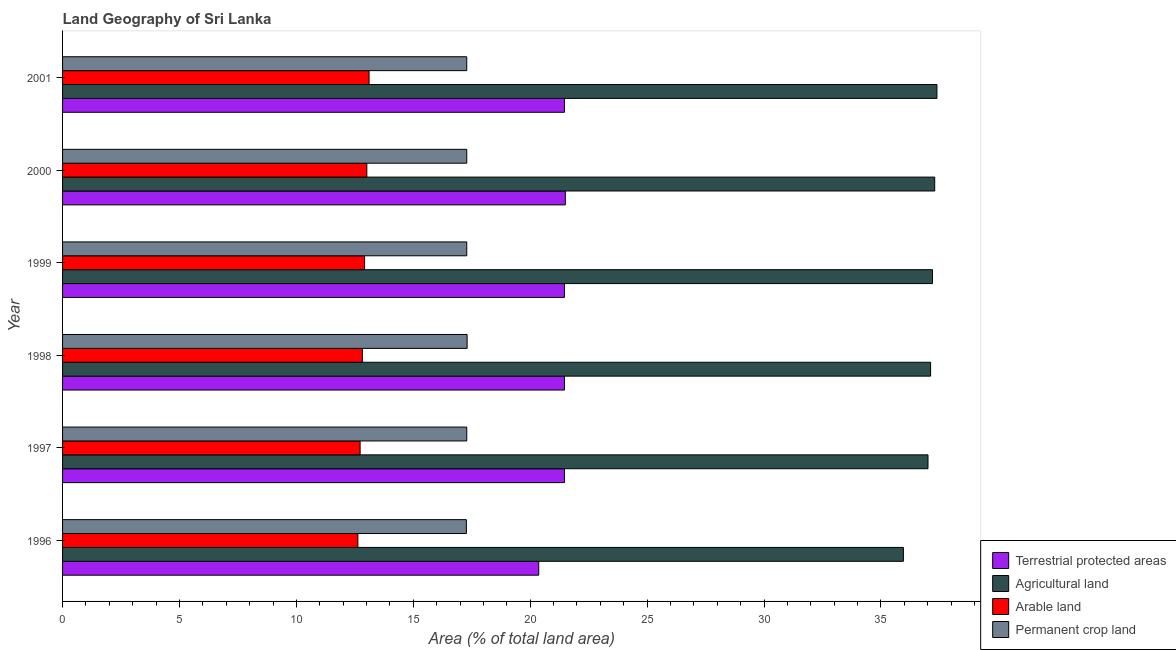How many different coloured bars are there?
Offer a terse response. 4. What is the percentage of area under agricultural land in 1997?
Ensure brevity in your answer.  37.01. Across all years, what is the maximum percentage of area under permanent crop land?
Your answer should be compact. 17.3. Across all years, what is the minimum percentage of area under arable land?
Your response must be concise. 12.63. What is the total percentage of area under arable land in the graph?
Your answer should be very brief. 77.21. What is the difference between the percentage of area under agricultural land in 1996 and that in 1997?
Your answer should be very brief. -1.05. What is the difference between the percentage of area under agricultural land in 1997 and the percentage of land under terrestrial protection in 1996?
Provide a short and direct response. 16.65. What is the average percentage of area under agricultural land per year?
Give a very brief answer. 37. In the year 1997, what is the difference between the percentage of land under terrestrial protection and percentage of area under agricultural land?
Give a very brief answer. -15.55. Is the percentage of area under arable land in 1997 less than that in 2000?
Make the answer very short. Yes. What is the difference between the highest and the second highest percentage of area under agricultural land?
Give a very brief answer. 0.1. What is the difference between the highest and the lowest percentage of area under agricultural land?
Your answer should be compact. 1.44. Is the sum of the percentage of land under terrestrial protection in 1998 and 1999 greater than the maximum percentage of area under arable land across all years?
Provide a short and direct response. Yes. What does the 3rd bar from the top in 1996 represents?
Ensure brevity in your answer.  Agricultural land. What does the 2nd bar from the bottom in 1996 represents?
Provide a short and direct response. Agricultural land. Are all the bars in the graph horizontal?
Your answer should be very brief. Yes. How many years are there in the graph?
Give a very brief answer. 6. Does the graph contain any zero values?
Keep it short and to the point. No. How many legend labels are there?
Your answer should be compact. 4. What is the title of the graph?
Give a very brief answer. Land Geography of Sri Lanka. Does "Arable land" appear as one of the legend labels in the graph?
Your answer should be very brief. Yes. What is the label or title of the X-axis?
Ensure brevity in your answer.  Area (% of total land area). What is the label or title of the Y-axis?
Your answer should be compact. Year. What is the Area (% of total land area) of Terrestrial protected areas in 1996?
Your response must be concise. 20.36. What is the Area (% of total land area) of Agricultural land in 1996?
Provide a short and direct response. 35.96. What is the Area (% of total land area) in Arable land in 1996?
Provide a succinct answer. 12.63. What is the Area (% of total land area) of Permanent crop land in 1996?
Ensure brevity in your answer.  17.27. What is the Area (% of total land area) in Terrestrial protected areas in 1997?
Provide a short and direct response. 21.46. What is the Area (% of total land area) in Agricultural land in 1997?
Your answer should be very brief. 37.01. What is the Area (% of total land area) of Arable land in 1997?
Your answer should be compact. 12.73. What is the Area (% of total land area) of Permanent crop land in 1997?
Provide a succinct answer. 17.29. What is the Area (% of total land area) of Terrestrial protected areas in 1998?
Keep it short and to the point. 21.46. What is the Area (% of total land area) of Agricultural land in 1998?
Your answer should be compact. 37.12. What is the Area (% of total land area) of Arable land in 1998?
Make the answer very short. 12.82. What is the Area (% of total land area) in Permanent crop land in 1998?
Offer a very short reply. 17.3. What is the Area (% of total land area) of Terrestrial protected areas in 1999?
Provide a short and direct response. 21.46. What is the Area (% of total land area) of Agricultural land in 1999?
Your response must be concise. 37.2. What is the Area (% of total land area) of Arable land in 1999?
Offer a very short reply. 12.92. What is the Area (% of total land area) of Permanent crop land in 1999?
Provide a succinct answer. 17.29. What is the Area (% of total land area) in Terrestrial protected areas in 2000?
Provide a succinct answer. 21.5. What is the Area (% of total land area) in Agricultural land in 2000?
Your response must be concise. 37.3. What is the Area (% of total land area) in Arable land in 2000?
Your answer should be compact. 13.01. What is the Area (% of total land area) in Permanent crop land in 2000?
Your answer should be compact. 17.29. What is the Area (% of total land area) of Terrestrial protected areas in 2001?
Ensure brevity in your answer.  21.46. What is the Area (% of total land area) in Agricultural land in 2001?
Your response must be concise. 37.39. What is the Area (% of total land area) in Arable land in 2001?
Your answer should be compact. 13.11. What is the Area (% of total land area) in Permanent crop land in 2001?
Offer a terse response. 17.29. Across all years, what is the maximum Area (% of total land area) of Terrestrial protected areas?
Give a very brief answer. 21.5. Across all years, what is the maximum Area (% of total land area) in Agricultural land?
Your answer should be compact. 37.39. Across all years, what is the maximum Area (% of total land area) in Arable land?
Provide a succinct answer. 13.11. Across all years, what is the maximum Area (% of total land area) in Permanent crop land?
Your answer should be compact. 17.3. Across all years, what is the minimum Area (% of total land area) of Terrestrial protected areas?
Provide a short and direct response. 20.36. Across all years, what is the minimum Area (% of total land area) of Agricultural land?
Provide a short and direct response. 35.96. Across all years, what is the minimum Area (% of total land area) of Arable land?
Offer a terse response. 12.63. Across all years, what is the minimum Area (% of total land area) in Permanent crop land?
Offer a terse response. 17.27. What is the total Area (% of total land area) in Terrestrial protected areas in the graph?
Give a very brief answer. 127.72. What is the total Area (% of total land area) in Agricultural land in the graph?
Offer a terse response. 221.99. What is the total Area (% of total land area) of Arable land in the graph?
Your response must be concise. 77.21. What is the total Area (% of total land area) of Permanent crop land in the graph?
Give a very brief answer. 103.72. What is the difference between the Area (% of total land area) in Terrestrial protected areas in 1996 and that in 1997?
Your answer should be very brief. -1.1. What is the difference between the Area (% of total land area) of Agricultural land in 1996 and that in 1997?
Ensure brevity in your answer.  -1.05. What is the difference between the Area (% of total land area) in Arable land in 1996 and that in 1997?
Your answer should be very brief. -0.1. What is the difference between the Area (% of total land area) in Permanent crop land in 1996 and that in 1997?
Offer a very short reply. -0.02. What is the difference between the Area (% of total land area) in Terrestrial protected areas in 1996 and that in 1998?
Offer a terse response. -1.1. What is the difference between the Area (% of total land area) in Agricultural land in 1996 and that in 1998?
Your response must be concise. -1.16. What is the difference between the Area (% of total land area) in Arable land in 1996 and that in 1998?
Give a very brief answer. -0.19. What is the difference between the Area (% of total land area) in Permanent crop land in 1996 and that in 1998?
Provide a succinct answer. -0.03. What is the difference between the Area (% of total land area) of Terrestrial protected areas in 1996 and that in 1999?
Your answer should be very brief. -1.1. What is the difference between the Area (% of total land area) of Agricultural land in 1996 and that in 1999?
Your answer should be very brief. -1.24. What is the difference between the Area (% of total land area) of Arable land in 1996 and that in 1999?
Offer a terse response. -0.29. What is the difference between the Area (% of total land area) of Permanent crop land in 1996 and that in 1999?
Make the answer very short. -0.02. What is the difference between the Area (% of total land area) in Terrestrial protected areas in 1996 and that in 2000?
Make the answer very short. -1.14. What is the difference between the Area (% of total land area) of Agricultural land in 1996 and that in 2000?
Keep it short and to the point. -1.34. What is the difference between the Area (% of total land area) in Arable land in 1996 and that in 2000?
Give a very brief answer. -0.38. What is the difference between the Area (% of total land area) of Permanent crop land in 1996 and that in 2000?
Offer a terse response. -0.02. What is the difference between the Area (% of total land area) of Terrestrial protected areas in 1996 and that in 2001?
Make the answer very short. -1.1. What is the difference between the Area (% of total land area) in Agricultural land in 1996 and that in 2001?
Your response must be concise. -1.44. What is the difference between the Area (% of total land area) of Arable land in 1996 and that in 2001?
Keep it short and to the point. -0.48. What is the difference between the Area (% of total land area) in Permanent crop land in 1996 and that in 2001?
Offer a terse response. -0.02. What is the difference between the Area (% of total land area) of Agricultural land in 1997 and that in 1998?
Offer a very short reply. -0.11. What is the difference between the Area (% of total land area) of Arable land in 1997 and that in 1998?
Make the answer very short. -0.1. What is the difference between the Area (% of total land area) in Permanent crop land in 1997 and that in 1998?
Ensure brevity in your answer.  -0.02. What is the difference between the Area (% of total land area) in Agricultural land in 1997 and that in 1999?
Your answer should be very brief. -0.19. What is the difference between the Area (% of total land area) of Arable land in 1997 and that in 1999?
Make the answer very short. -0.19. What is the difference between the Area (% of total land area) in Permanent crop land in 1997 and that in 1999?
Your answer should be very brief. 0. What is the difference between the Area (% of total land area) in Terrestrial protected areas in 1997 and that in 2000?
Your response must be concise. -0.04. What is the difference between the Area (% of total land area) in Agricultural land in 1997 and that in 2000?
Offer a terse response. -0.29. What is the difference between the Area (% of total land area) of Arable land in 1997 and that in 2000?
Your response must be concise. -0.29. What is the difference between the Area (% of total land area) in Agricultural land in 1997 and that in 2001?
Offer a very short reply. -0.38. What is the difference between the Area (% of total land area) in Arable land in 1997 and that in 2001?
Your answer should be very brief. -0.38. What is the difference between the Area (% of total land area) in Terrestrial protected areas in 1998 and that in 1999?
Ensure brevity in your answer.  0. What is the difference between the Area (% of total land area) in Agricultural land in 1998 and that in 1999?
Your answer should be compact. -0.08. What is the difference between the Area (% of total land area) of Arable land in 1998 and that in 1999?
Offer a very short reply. -0.1. What is the difference between the Area (% of total land area) of Permanent crop land in 1998 and that in 1999?
Give a very brief answer. 0.02. What is the difference between the Area (% of total land area) in Terrestrial protected areas in 1998 and that in 2000?
Your answer should be very brief. -0.04. What is the difference between the Area (% of total land area) of Agricultural land in 1998 and that in 2000?
Offer a terse response. -0.18. What is the difference between the Area (% of total land area) in Arable land in 1998 and that in 2000?
Provide a short and direct response. -0.19. What is the difference between the Area (% of total land area) in Permanent crop land in 1998 and that in 2000?
Keep it short and to the point. 0.02. What is the difference between the Area (% of total land area) of Terrestrial protected areas in 1998 and that in 2001?
Provide a succinct answer. 0. What is the difference between the Area (% of total land area) of Agricultural land in 1998 and that in 2001?
Offer a terse response. -0.27. What is the difference between the Area (% of total land area) of Arable land in 1998 and that in 2001?
Your answer should be compact. -0.29. What is the difference between the Area (% of total land area) of Permanent crop land in 1998 and that in 2001?
Offer a very short reply. 0.02. What is the difference between the Area (% of total land area) in Terrestrial protected areas in 1999 and that in 2000?
Make the answer very short. -0.04. What is the difference between the Area (% of total land area) in Agricultural land in 1999 and that in 2000?
Provide a succinct answer. -0.1. What is the difference between the Area (% of total land area) of Arable land in 1999 and that in 2000?
Ensure brevity in your answer.  -0.1. What is the difference between the Area (% of total land area) of Permanent crop land in 1999 and that in 2000?
Offer a very short reply. 0. What is the difference between the Area (% of total land area) in Terrestrial protected areas in 1999 and that in 2001?
Provide a succinct answer. 0. What is the difference between the Area (% of total land area) in Agricultural land in 1999 and that in 2001?
Keep it short and to the point. -0.19. What is the difference between the Area (% of total land area) of Arable land in 1999 and that in 2001?
Your response must be concise. -0.19. What is the difference between the Area (% of total land area) of Permanent crop land in 1999 and that in 2001?
Keep it short and to the point. 0. What is the difference between the Area (% of total land area) in Terrestrial protected areas in 2000 and that in 2001?
Keep it short and to the point. 0.04. What is the difference between the Area (% of total land area) in Agricultural land in 2000 and that in 2001?
Provide a succinct answer. -0.1. What is the difference between the Area (% of total land area) in Arable land in 2000 and that in 2001?
Keep it short and to the point. -0.1. What is the difference between the Area (% of total land area) in Terrestrial protected areas in 1996 and the Area (% of total land area) in Agricultural land in 1997?
Offer a terse response. -16.65. What is the difference between the Area (% of total land area) in Terrestrial protected areas in 1996 and the Area (% of total land area) in Arable land in 1997?
Provide a short and direct response. 7.64. What is the difference between the Area (% of total land area) of Terrestrial protected areas in 1996 and the Area (% of total land area) of Permanent crop land in 1997?
Offer a very short reply. 3.08. What is the difference between the Area (% of total land area) in Agricultural land in 1996 and the Area (% of total land area) in Arable land in 1997?
Provide a short and direct response. 23.23. What is the difference between the Area (% of total land area) in Agricultural land in 1996 and the Area (% of total land area) in Permanent crop land in 1997?
Your answer should be very brief. 18.67. What is the difference between the Area (% of total land area) in Arable land in 1996 and the Area (% of total land area) in Permanent crop land in 1997?
Make the answer very short. -4.66. What is the difference between the Area (% of total land area) of Terrestrial protected areas in 1996 and the Area (% of total land area) of Agricultural land in 1998?
Offer a very short reply. -16.76. What is the difference between the Area (% of total land area) in Terrestrial protected areas in 1996 and the Area (% of total land area) in Arable land in 1998?
Ensure brevity in your answer.  7.54. What is the difference between the Area (% of total land area) in Terrestrial protected areas in 1996 and the Area (% of total land area) in Permanent crop land in 1998?
Your answer should be compact. 3.06. What is the difference between the Area (% of total land area) of Agricultural land in 1996 and the Area (% of total land area) of Arable land in 1998?
Your answer should be very brief. 23.14. What is the difference between the Area (% of total land area) of Agricultural land in 1996 and the Area (% of total land area) of Permanent crop land in 1998?
Offer a very short reply. 18.66. What is the difference between the Area (% of total land area) of Arable land in 1996 and the Area (% of total land area) of Permanent crop land in 1998?
Your answer should be compact. -4.67. What is the difference between the Area (% of total land area) in Terrestrial protected areas in 1996 and the Area (% of total land area) in Agricultural land in 1999?
Offer a terse response. -16.84. What is the difference between the Area (% of total land area) of Terrestrial protected areas in 1996 and the Area (% of total land area) of Arable land in 1999?
Provide a short and direct response. 7.45. What is the difference between the Area (% of total land area) of Terrestrial protected areas in 1996 and the Area (% of total land area) of Permanent crop land in 1999?
Make the answer very short. 3.08. What is the difference between the Area (% of total land area) in Agricultural land in 1996 and the Area (% of total land area) in Arable land in 1999?
Ensure brevity in your answer.  23.04. What is the difference between the Area (% of total land area) of Agricultural land in 1996 and the Area (% of total land area) of Permanent crop land in 1999?
Make the answer very short. 18.67. What is the difference between the Area (% of total land area) of Arable land in 1996 and the Area (% of total land area) of Permanent crop land in 1999?
Offer a terse response. -4.66. What is the difference between the Area (% of total land area) in Terrestrial protected areas in 1996 and the Area (% of total land area) in Agricultural land in 2000?
Keep it short and to the point. -16.93. What is the difference between the Area (% of total land area) in Terrestrial protected areas in 1996 and the Area (% of total land area) in Arable land in 2000?
Ensure brevity in your answer.  7.35. What is the difference between the Area (% of total land area) of Terrestrial protected areas in 1996 and the Area (% of total land area) of Permanent crop land in 2000?
Your answer should be very brief. 3.08. What is the difference between the Area (% of total land area) of Agricultural land in 1996 and the Area (% of total land area) of Arable land in 2000?
Keep it short and to the point. 22.95. What is the difference between the Area (% of total land area) of Agricultural land in 1996 and the Area (% of total land area) of Permanent crop land in 2000?
Offer a very short reply. 18.67. What is the difference between the Area (% of total land area) in Arable land in 1996 and the Area (% of total land area) in Permanent crop land in 2000?
Offer a very short reply. -4.66. What is the difference between the Area (% of total land area) of Terrestrial protected areas in 1996 and the Area (% of total land area) of Agricultural land in 2001?
Your answer should be compact. -17.03. What is the difference between the Area (% of total land area) of Terrestrial protected areas in 1996 and the Area (% of total land area) of Arable land in 2001?
Offer a terse response. 7.26. What is the difference between the Area (% of total land area) in Terrestrial protected areas in 1996 and the Area (% of total land area) in Permanent crop land in 2001?
Keep it short and to the point. 3.08. What is the difference between the Area (% of total land area) of Agricultural land in 1996 and the Area (% of total land area) of Arable land in 2001?
Your answer should be compact. 22.85. What is the difference between the Area (% of total land area) of Agricultural land in 1996 and the Area (% of total land area) of Permanent crop land in 2001?
Ensure brevity in your answer.  18.67. What is the difference between the Area (% of total land area) of Arable land in 1996 and the Area (% of total land area) of Permanent crop land in 2001?
Provide a short and direct response. -4.66. What is the difference between the Area (% of total land area) of Terrestrial protected areas in 1997 and the Area (% of total land area) of Agricultural land in 1998?
Give a very brief answer. -15.66. What is the difference between the Area (% of total land area) in Terrestrial protected areas in 1997 and the Area (% of total land area) in Arable land in 1998?
Provide a succinct answer. 8.64. What is the difference between the Area (% of total land area) in Terrestrial protected areas in 1997 and the Area (% of total land area) in Permanent crop land in 1998?
Provide a succinct answer. 4.16. What is the difference between the Area (% of total land area) of Agricultural land in 1997 and the Area (% of total land area) of Arable land in 1998?
Keep it short and to the point. 24.19. What is the difference between the Area (% of total land area) of Agricultural land in 1997 and the Area (% of total land area) of Permanent crop land in 1998?
Your response must be concise. 19.71. What is the difference between the Area (% of total land area) in Arable land in 1997 and the Area (% of total land area) in Permanent crop land in 1998?
Offer a very short reply. -4.58. What is the difference between the Area (% of total land area) of Terrestrial protected areas in 1997 and the Area (% of total land area) of Agricultural land in 1999?
Give a very brief answer. -15.74. What is the difference between the Area (% of total land area) in Terrestrial protected areas in 1997 and the Area (% of total land area) in Arable land in 1999?
Provide a succinct answer. 8.55. What is the difference between the Area (% of total land area) of Terrestrial protected areas in 1997 and the Area (% of total land area) of Permanent crop land in 1999?
Your answer should be compact. 4.18. What is the difference between the Area (% of total land area) of Agricultural land in 1997 and the Area (% of total land area) of Arable land in 1999?
Your answer should be very brief. 24.09. What is the difference between the Area (% of total land area) of Agricultural land in 1997 and the Area (% of total land area) of Permanent crop land in 1999?
Provide a succinct answer. 19.73. What is the difference between the Area (% of total land area) of Arable land in 1997 and the Area (% of total land area) of Permanent crop land in 1999?
Give a very brief answer. -4.56. What is the difference between the Area (% of total land area) in Terrestrial protected areas in 1997 and the Area (% of total land area) in Agricultural land in 2000?
Keep it short and to the point. -15.83. What is the difference between the Area (% of total land area) in Terrestrial protected areas in 1997 and the Area (% of total land area) in Arable land in 2000?
Give a very brief answer. 8.45. What is the difference between the Area (% of total land area) in Terrestrial protected areas in 1997 and the Area (% of total land area) in Permanent crop land in 2000?
Your response must be concise. 4.18. What is the difference between the Area (% of total land area) in Agricultural land in 1997 and the Area (% of total land area) in Arable land in 2000?
Your answer should be very brief. 24. What is the difference between the Area (% of total land area) in Agricultural land in 1997 and the Area (% of total land area) in Permanent crop land in 2000?
Give a very brief answer. 19.73. What is the difference between the Area (% of total land area) in Arable land in 1997 and the Area (% of total land area) in Permanent crop land in 2000?
Ensure brevity in your answer.  -4.56. What is the difference between the Area (% of total land area) in Terrestrial protected areas in 1997 and the Area (% of total land area) in Agricultural land in 2001?
Ensure brevity in your answer.  -15.93. What is the difference between the Area (% of total land area) in Terrestrial protected areas in 1997 and the Area (% of total land area) in Arable land in 2001?
Make the answer very short. 8.36. What is the difference between the Area (% of total land area) in Terrestrial protected areas in 1997 and the Area (% of total land area) in Permanent crop land in 2001?
Keep it short and to the point. 4.18. What is the difference between the Area (% of total land area) of Agricultural land in 1997 and the Area (% of total land area) of Arable land in 2001?
Your response must be concise. 23.9. What is the difference between the Area (% of total land area) in Agricultural land in 1997 and the Area (% of total land area) in Permanent crop land in 2001?
Keep it short and to the point. 19.73. What is the difference between the Area (% of total land area) in Arable land in 1997 and the Area (% of total land area) in Permanent crop land in 2001?
Ensure brevity in your answer.  -4.56. What is the difference between the Area (% of total land area) in Terrestrial protected areas in 1998 and the Area (% of total land area) in Agricultural land in 1999?
Your answer should be compact. -15.74. What is the difference between the Area (% of total land area) of Terrestrial protected areas in 1998 and the Area (% of total land area) of Arable land in 1999?
Your answer should be compact. 8.55. What is the difference between the Area (% of total land area) in Terrestrial protected areas in 1998 and the Area (% of total land area) in Permanent crop land in 1999?
Keep it short and to the point. 4.18. What is the difference between the Area (% of total land area) in Agricultural land in 1998 and the Area (% of total land area) in Arable land in 1999?
Your response must be concise. 24.21. What is the difference between the Area (% of total land area) of Agricultural land in 1998 and the Area (% of total land area) of Permanent crop land in 1999?
Keep it short and to the point. 19.84. What is the difference between the Area (% of total land area) of Arable land in 1998 and the Area (% of total land area) of Permanent crop land in 1999?
Your answer should be very brief. -4.46. What is the difference between the Area (% of total land area) in Terrestrial protected areas in 1998 and the Area (% of total land area) in Agricultural land in 2000?
Your answer should be very brief. -15.83. What is the difference between the Area (% of total land area) of Terrestrial protected areas in 1998 and the Area (% of total land area) of Arable land in 2000?
Ensure brevity in your answer.  8.45. What is the difference between the Area (% of total land area) in Terrestrial protected areas in 1998 and the Area (% of total land area) in Permanent crop land in 2000?
Offer a terse response. 4.18. What is the difference between the Area (% of total land area) in Agricultural land in 1998 and the Area (% of total land area) in Arable land in 2000?
Offer a very short reply. 24.11. What is the difference between the Area (% of total land area) in Agricultural land in 1998 and the Area (% of total land area) in Permanent crop land in 2000?
Your answer should be compact. 19.84. What is the difference between the Area (% of total land area) of Arable land in 1998 and the Area (% of total land area) of Permanent crop land in 2000?
Your response must be concise. -4.46. What is the difference between the Area (% of total land area) in Terrestrial protected areas in 1998 and the Area (% of total land area) in Agricultural land in 2001?
Provide a succinct answer. -15.93. What is the difference between the Area (% of total land area) of Terrestrial protected areas in 1998 and the Area (% of total land area) of Arable land in 2001?
Give a very brief answer. 8.36. What is the difference between the Area (% of total land area) of Terrestrial protected areas in 1998 and the Area (% of total land area) of Permanent crop land in 2001?
Keep it short and to the point. 4.18. What is the difference between the Area (% of total land area) of Agricultural land in 1998 and the Area (% of total land area) of Arable land in 2001?
Give a very brief answer. 24.02. What is the difference between the Area (% of total land area) in Agricultural land in 1998 and the Area (% of total land area) in Permanent crop land in 2001?
Provide a short and direct response. 19.84. What is the difference between the Area (% of total land area) of Arable land in 1998 and the Area (% of total land area) of Permanent crop land in 2001?
Make the answer very short. -4.46. What is the difference between the Area (% of total land area) of Terrestrial protected areas in 1999 and the Area (% of total land area) of Agricultural land in 2000?
Your response must be concise. -15.83. What is the difference between the Area (% of total land area) of Terrestrial protected areas in 1999 and the Area (% of total land area) of Arable land in 2000?
Keep it short and to the point. 8.45. What is the difference between the Area (% of total land area) of Terrestrial protected areas in 1999 and the Area (% of total land area) of Permanent crop land in 2000?
Your response must be concise. 4.18. What is the difference between the Area (% of total land area) of Agricultural land in 1999 and the Area (% of total land area) of Arable land in 2000?
Give a very brief answer. 24.19. What is the difference between the Area (% of total land area) in Agricultural land in 1999 and the Area (% of total land area) in Permanent crop land in 2000?
Provide a short and direct response. 19.92. What is the difference between the Area (% of total land area) of Arable land in 1999 and the Area (% of total land area) of Permanent crop land in 2000?
Offer a very short reply. -4.37. What is the difference between the Area (% of total land area) of Terrestrial protected areas in 1999 and the Area (% of total land area) of Agricultural land in 2001?
Your answer should be very brief. -15.93. What is the difference between the Area (% of total land area) in Terrestrial protected areas in 1999 and the Area (% of total land area) in Arable land in 2001?
Your answer should be very brief. 8.36. What is the difference between the Area (% of total land area) of Terrestrial protected areas in 1999 and the Area (% of total land area) of Permanent crop land in 2001?
Make the answer very short. 4.18. What is the difference between the Area (% of total land area) of Agricultural land in 1999 and the Area (% of total land area) of Arable land in 2001?
Ensure brevity in your answer.  24.09. What is the difference between the Area (% of total land area) in Agricultural land in 1999 and the Area (% of total land area) in Permanent crop land in 2001?
Offer a terse response. 19.92. What is the difference between the Area (% of total land area) in Arable land in 1999 and the Area (% of total land area) in Permanent crop land in 2001?
Offer a terse response. -4.37. What is the difference between the Area (% of total land area) in Terrestrial protected areas in 2000 and the Area (% of total land area) in Agricultural land in 2001?
Ensure brevity in your answer.  -15.89. What is the difference between the Area (% of total land area) of Terrestrial protected areas in 2000 and the Area (% of total land area) of Arable land in 2001?
Offer a terse response. 8.39. What is the difference between the Area (% of total land area) in Terrestrial protected areas in 2000 and the Area (% of total land area) in Permanent crop land in 2001?
Offer a very short reply. 4.22. What is the difference between the Area (% of total land area) of Agricultural land in 2000 and the Area (% of total land area) of Arable land in 2001?
Keep it short and to the point. 24.19. What is the difference between the Area (% of total land area) of Agricultural land in 2000 and the Area (% of total land area) of Permanent crop land in 2001?
Keep it short and to the point. 20.01. What is the difference between the Area (% of total land area) of Arable land in 2000 and the Area (% of total land area) of Permanent crop land in 2001?
Your answer should be very brief. -4.27. What is the average Area (% of total land area) in Terrestrial protected areas per year?
Provide a short and direct response. 21.29. What is the average Area (% of total land area) of Agricultural land per year?
Provide a short and direct response. 37. What is the average Area (% of total land area) of Arable land per year?
Ensure brevity in your answer.  12.87. What is the average Area (% of total land area) in Permanent crop land per year?
Give a very brief answer. 17.29. In the year 1996, what is the difference between the Area (% of total land area) of Terrestrial protected areas and Area (% of total land area) of Agricultural land?
Give a very brief answer. -15.6. In the year 1996, what is the difference between the Area (% of total land area) of Terrestrial protected areas and Area (% of total land area) of Arable land?
Offer a very short reply. 7.73. In the year 1996, what is the difference between the Area (% of total land area) of Terrestrial protected areas and Area (% of total land area) of Permanent crop land?
Provide a short and direct response. 3.09. In the year 1996, what is the difference between the Area (% of total land area) of Agricultural land and Area (% of total land area) of Arable land?
Ensure brevity in your answer.  23.33. In the year 1996, what is the difference between the Area (% of total land area) of Agricultural land and Area (% of total land area) of Permanent crop land?
Your answer should be very brief. 18.69. In the year 1996, what is the difference between the Area (% of total land area) of Arable land and Area (% of total land area) of Permanent crop land?
Your response must be concise. -4.64. In the year 1997, what is the difference between the Area (% of total land area) in Terrestrial protected areas and Area (% of total land area) in Agricultural land?
Your response must be concise. -15.55. In the year 1997, what is the difference between the Area (% of total land area) in Terrestrial protected areas and Area (% of total land area) in Arable land?
Provide a succinct answer. 8.74. In the year 1997, what is the difference between the Area (% of total land area) of Terrestrial protected areas and Area (% of total land area) of Permanent crop land?
Ensure brevity in your answer.  4.18. In the year 1997, what is the difference between the Area (% of total land area) in Agricultural land and Area (% of total land area) in Arable land?
Provide a short and direct response. 24.29. In the year 1997, what is the difference between the Area (% of total land area) of Agricultural land and Area (% of total land area) of Permanent crop land?
Your answer should be very brief. 19.73. In the year 1997, what is the difference between the Area (% of total land area) of Arable land and Area (% of total land area) of Permanent crop land?
Keep it short and to the point. -4.56. In the year 1998, what is the difference between the Area (% of total land area) of Terrestrial protected areas and Area (% of total land area) of Agricultural land?
Keep it short and to the point. -15.66. In the year 1998, what is the difference between the Area (% of total land area) of Terrestrial protected areas and Area (% of total land area) of Arable land?
Make the answer very short. 8.64. In the year 1998, what is the difference between the Area (% of total land area) in Terrestrial protected areas and Area (% of total land area) in Permanent crop land?
Offer a very short reply. 4.16. In the year 1998, what is the difference between the Area (% of total land area) of Agricultural land and Area (% of total land area) of Arable land?
Your answer should be compact. 24.3. In the year 1998, what is the difference between the Area (% of total land area) in Agricultural land and Area (% of total land area) in Permanent crop land?
Keep it short and to the point. 19.82. In the year 1998, what is the difference between the Area (% of total land area) of Arable land and Area (% of total land area) of Permanent crop land?
Keep it short and to the point. -4.48. In the year 1999, what is the difference between the Area (% of total land area) in Terrestrial protected areas and Area (% of total land area) in Agricultural land?
Offer a very short reply. -15.74. In the year 1999, what is the difference between the Area (% of total land area) in Terrestrial protected areas and Area (% of total land area) in Arable land?
Give a very brief answer. 8.55. In the year 1999, what is the difference between the Area (% of total land area) of Terrestrial protected areas and Area (% of total land area) of Permanent crop land?
Give a very brief answer. 4.18. In the year 1999, what is the difference between the Area (% of total land area) of Agricultural land and Area (% of total land area) of Arable land?
Ensure brevity in your answer.  24.29. In the year 1999, what is the difference between the Area (% of total land area) in Agricultural land and Area (% of total land area) in Permanent crop land?
Give a very brief answer. 19.92. In the year 1999, what is the difference between the Area (% of total land area) in Arable land and Area (% of total land area) in Permanent crop land?
Your response must be concise. -4.37. In the year 2000, what is the difference between the Area (% of total land area) in Terrestrial protected areas and Area (% of total land area) in Agricultural land?
Provide a short and direct response. -15.8. In the year 2000, what is the difference between the Area (% of total land area) of Terrestrial protected areas and Area (% of total land area) of Arable land?
Keep it short and to the point. 8.49. In the year 2000, what is the difference between the Area (% of total land area) in Terrestrial protected areas and Area (% of total land area) in Permanent crop land?
Offer a very short reply. 4.22. In the year 2000, what is the difference between the Area (% of total land area) of Agricultural land and Area (% of total land area) of Arable land?
Your response must be concise. 24.29. In the year 2000, what is the difference between the Area (% of total land area) in Agricultural land and Area (% of total land area) in Permanent crop land?
Offer a terse response. 20.01. In the year 2000, what is the difference between the Area (% of total land area) in Arable land and Area (% of total land area) in Permanent crop land?
Offer a very short reply. -4.27. In the year 2001, what is the difference between the Area (% of total land area) of Terrestrial protected areas and Area (% of total land area) of Agricultural land?
Provide a short and direct response. -15.93. In the year 2001, what is the difference between the Area (% of total land area) of Terrestrial protected areas and Area (% of total land area) of Arable land?
Keep it short and to the point. 8.36. In the year 2001, what is the difference between the Area (% of total land area) in Terrestrial protected areas and Area (% of total land area) in Permanent crop land?
Keep it short and to the point. 4.18. In the year 2001, what is the difference between the Area (% of total land area) in Agricultural land and Area (% of total land area) in Arable land?
Provide a short and direct response. 24.29. In the year 2001, what is the difference between the Area (% of total land area) in Agricultural land and Area (% of total land area) in Permanent crop land?
Provide a succinct answer. 20.11. In the year 2001, what is the difference between the Area (% of total land area) in Arable land and Area (% of total land area) in Permanent crop land?
Offer a very short reply. -4.18. What is the ratio of the Area (% of total land area) in Terrestrial protected areas in 1996 to that in 1997?
Your response must be concise. 0.95. What is the ratio of the Area (% of total land area) of Agricultural land in 1996 to that in 1997?
Your answer should be compact. 0.97. What is the ratio of the Area (% of total land area) in Terrestrial protected areas in 1996 to that in 1998?
Offer a terse response. 0.95. What is the ratio of the Area (% of total land area) in Agricultural land in 1996 to that in 1998?
Ensure brevity in your answer.  0.97. What is the ratio of the Area (% of total land area) in Arable land in 1996 to that in 1998?
Make the answer very short. 0.99. What is the ratio of the Area (% of total land area) in Permanent crop land in 1996 to that in 1998?
Give a very brief answer. 1. What is the ratio of the Area (% of total land area) in Terrestrial protected areas in 1996 to that in 1999?
Make the answer very short. 0.95. What is the ratio of the Area (% of total land area) in Agricultural land in 1996 to that in 1999?
Your answer should be compact. 0.97. What is the ratio of the Area (% of total land area) of Arable land in 1996 to that in 1999?
Provide a succinct answer. 0.98. What is the ratio of the Area (% of total land area) of Terrestrial protected areas in 1996 to that in 2000?
Offer a very short reply. 0.95. What is the ratio of the Area (% of total land area) of Agricultural land in 1996 to that in 2000?
Your answer should be compact. 0.96. What is the ratio of the Area (% of total land area) of Arable land in 1996 to that in 2000?
Make the answer very short. 0.97. What is the ratio of the Area (% of total land area) of Terrestrial protected areas in 1996 to that in 2001?
Your response must be concise. 0.95. What is the ratio of the Area (% of total land area) of Agricultural land in 1996 to that in 2001?
Offer a very short reply. 0.96. What is the ratio of the Area (% of total land area) of Arable land in 1996 to that in 2001?
Provide a short and direct response. 0.96. What is the ratio of the Area (% of total land area) in Permanent crop land in 1996 to that in 2001?
Your answer should be very brief. 1. What is the ratio of the Area (% of total land area) in Terrestrial protected areas in 1997 to that in 1998?
Offer a terse response. 1. What is the ratio of the Area (% of total land area) of Permanent crop land in 1997 to that in 1998?
Offer a terse response. 1. What is the ratio of the Area (% of total land area) of Terrestrial protected areas in 1997 to that in 1999?
Ensure brevity in your answer.  1. What is the ratio of the Area (% of total land area) in Agricultural land in 1997 to that in 1999?
Provide a succinct answer. 0.99. What is the ratio of the Area (% of total land area) in Arable land in 1997 to that in 1999?
Provide a succinct answer. 0.99. What is the ratio of the Area (% of total land area) of Terrestrial protected areas in 1997 to that in 2000?
Keep it short and to the point. 1. What is the ratio of the Area (% of total land area) of Arable land in 1997 to that in 2000?
Your response must be concise. 0.98. What is the ratio of the Area (% of total land area) of Agricultural land in 1997 to that in 2001?
Provide a succinct answer. 0.99. What is the ratio of the Area (% of total land area) in Arable land in 1997 to that in 2001?
Your answer should be compact. 0.97. What is the ratio of the Area (% of total land area) of Permanent crop land in 1997 to that in 2001?
Make the answer very short. 1. What is the ratio of the Area (% of total land area) of Terrestrial protected areas in 1998 to that in 1999?
Provide a short and direct response. 1. What is the ratio of the Area (% of total land area) in Arable land in 1998 to that in 1999?
Provide a short and direct response. 0.99. What is the ratio of the Area (% of total land area) in Terrestrial protected areas in 1998 to that in 2000?
Make the answer very short. 1. What is the ratio of the Area (% of total land area) of Agricultural land in 1998 to that in 2000?
Your answer should be very brief. 1. What is the ratio of the Area (% of total land area) in Arable land in 1998 to that in 2000?
Offer a terse response. 0.99. What is the ratio of the Area (% of total land area) in Terrestrial protected areas in 1998 to that in 2001?
Provide a succinct answer. 1. What is the ratio of the Area (% of total land area) in Arable land in 1998 to that in 2001?
Your response must be concise. 0.98. What is the ratio of the Area (% of total land area) in Terrestrial protected areas in 1999 to that in 2000?
Your response must be concise. 1. What is the ratio of the Area (% of total land area) of Arable land in 1999 to that in 2000?
Give a very brief answer. 0.99. What is the ratio of the Area (% of total land area) in Terrestrial protected areas in 1999 to that in 2001?
Ensure brevity in your answer.  1. What is the ratio of the Area (% of total land area) of Arable land in 1999 to that in 2001?
Give a very brief answer. 0.99. What is the ratio of the Area (% of total land area) of Terrestrial protected areas in 2000 to that in 2001?
Make the answer very short. 1. What is the ratio of the Area (% of total land area) in Arable land in 2000 to that in 2001?
Offer a terse response. 0.99. What is the ratio of the Area (% of total land area) in Permanent crop land in 2000 to that in 2001?
Provide a succinct answer. 1. What is the difference between the highest and the second highest Area (% of total land area) of Terrestrial protected areas?
Provide a short and direct response. 0.04. What is the difference between the highest and the second highest Area (% of total land area) of Agricultural land?
Your response must be concise. 0.1. What is the difference between the highest and the second highest Area (% of total land area) of Arable land?
Provide a succinct answer. 0.1. What is the difference between the highest and the second highest Area (% of total land area) in Permanent crop land?
Your answer should be very brief. 0.02. What is the difference between the highest and the lowest Area (% of total land area) of Terrestrial protected areas?
Give a very brief answer. 1.14. What is the difference between the highest and the lowest Area (% of total land area) in Agricultural land?
Make the answer very short. 1.44. What is the difference between the highest and the lowest Area (% of total land area) in Arable land?
Your response must be concise. 0.48. What is the difference between the highest and the lowest Area (% of total land area) of Permanent crop land?
Your answer should be compact. 0.03. 